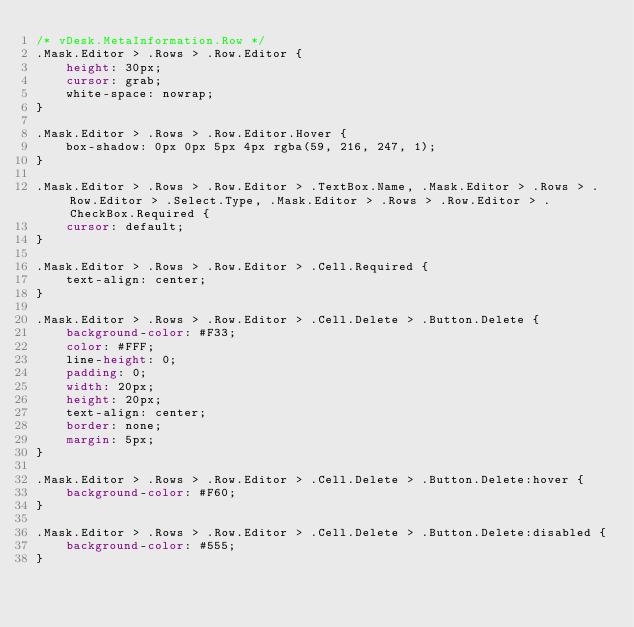Convert code to text. <code><loc_0><loc_0><loc_500><loc_500><_CSS_>/* vDesk.MetaInformation.Row */
.Mask.Editor > .Rows > .Row.Editor {
    height: 30px;
    cursor: grab;
    white-space: nowrap;
}

.Mask.Editor > .Rows > .Row.Editor.Hover {
    box-shadow: 0px 0px 5px 4px rgba(59, 216, 247, 1);
}

.Mask.Editor > .Rows > .Row.Editor > .TextBox.Name, .Mask.Editor > .Rows > .Row.Editor > .Select.Type, .Mask.Editor > .Rows > .Row.Editor > .CheckBox.Required {
    cursor: default;
}

.Mask.Editor > .Rows > .Row.Editor > .Cell.Required {
    text-align: center;
}

.Mask.Editor > .Rows > .Row.Editor > .Cell.Delete > .Button.Delete {
    background-color: #F33;
    color: #FFF;
    line-height: 0;
    padding: 0;
    width: 20px;
    height: 20px;
    text-align: center;
    border: none;
    margin: 5px;
}

.Mask.Editor > .Rows > .Row.Editor > .Cell.Delete > .Button.Delete:hover {
    background-color: #F60;
}

.Mask.Editor > .Rows > .Row.Editor > .Cell.Delete > .Button.Delete:disabled {
    background-color: #555;
}</code> 